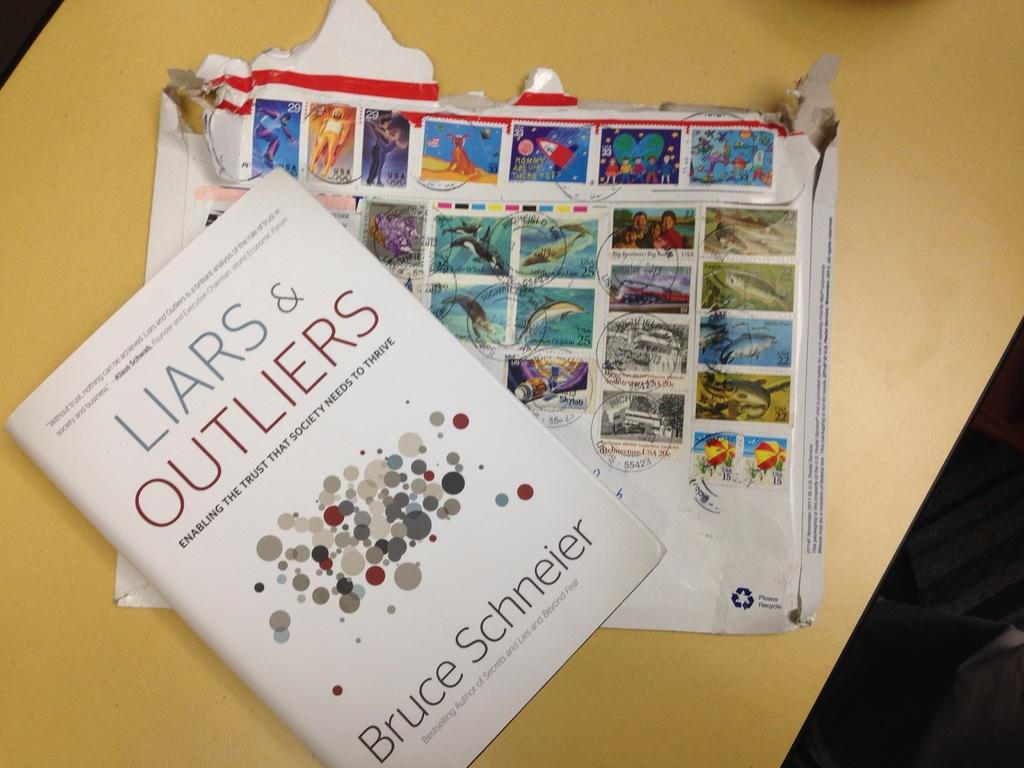Provide a one-sentence caption for the provided image. A book titled Liars and outliers by Bruce Schneier. 